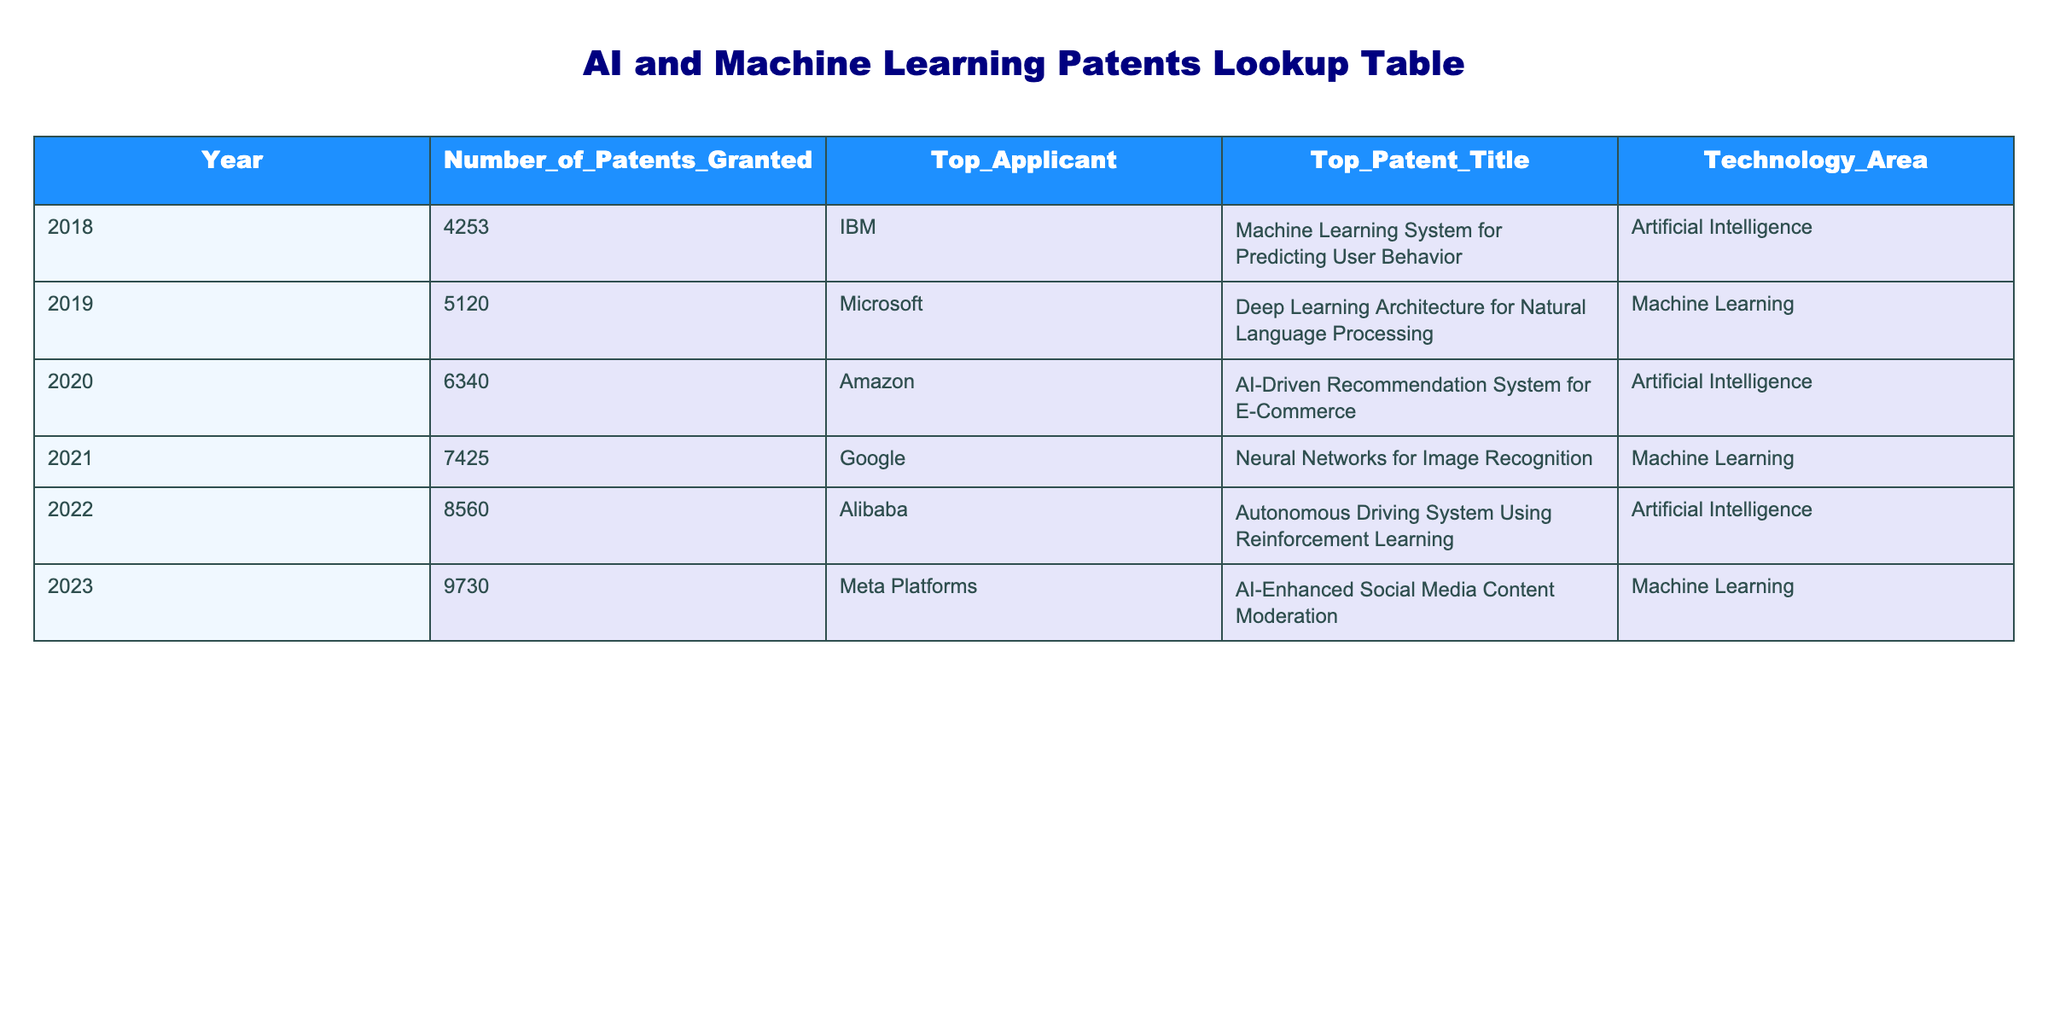What year had the highest number of patents granted? The table lists the number of patents granted each year from 2018 to 2023. By comparing the values, 9730 patents were granted in 2023, which is the highest number compared to previous years.
Answer: 2023 Who was the top applicant in 2021? According to the table, the top applicant for patents granted in 2021 is Google. This is found directly in the corresponding row for that year.
Answer: Google How many patents were granted in 2019 compared to 2018? Looking at the table, 5120 patents were granted in 2019 and 4253 patents were granted in 2018. To find the difference, subtract 2018 from 2019: 5120 - 4253 = 867.
Answer: 867 What is the total number of patents granted from 2018 to 2022? To find the total, we add the number of patents for each year: 4253 + 5120 + 6340 + 7425 + 8560 = 23,698. This involves basic summation of the values provided in the table.
Answer: 23698 Is the top patent title for 2022 related to artificial intelligence? By checking the technology area column for the year 2022, the title "Autonomous Driving System Using Reinforcement Learning" is categorized under artificial intelligence, indicating a relationship.
Answer: Yes What was the increase in the number of patents granted from 2020 to 2023? The table shows that 6340 patents were granted in 2020 and 9730 in 2023. To find the increase, subtract the 2020 value from the 2023 value: 9730 - 6340 = 3390.
Answer: 3390 How many patents were granted in the year with the highest increase from the previous year? First, we need to evaluate the year-to-year increases: 2018 to 2019 (867), 2019 to 2020 (1220), 2020 to 2021 (1085), 2021 to 2022 (1355), and 2022 to 2023 (1170). The highest increase occurred from 2019 to 2020 with 1220 patents granted in 2020.
Answer: 6340 Did Microsoft have a higher number of patents granted than IBM? From the table, Microsoft was the top applicant in 2019 with 5120 patents, while IBM was the top applicant in 2018 with 4253 patents. Comparing these two values, Microsoft has a higher number of patents granted than IBM.
Answer: Yes Which year had the least increase in the number of patents granted compared to its preceding year? By checking the year-to-year increase: 2018 to 2019 (867), 2019 to 2020 (1220), 2020 to 2021 (1085), 2021 to 2022 (1355), and 2022 to 2023 (1170). The least increase was from 2020 to 2021 with 1085 patents.
Answer: 2021 